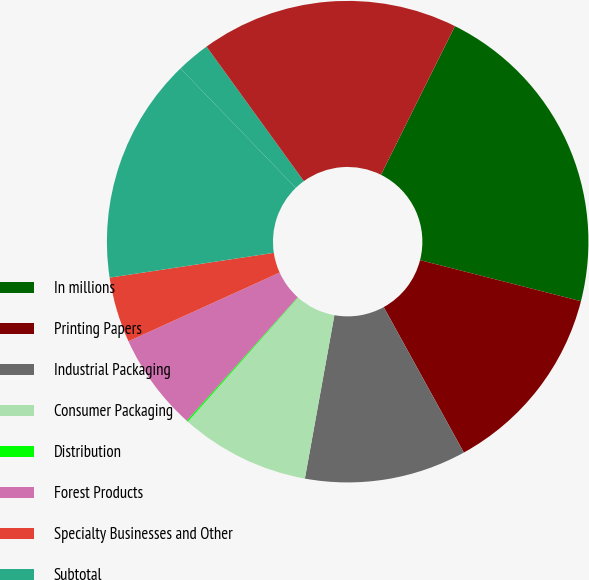<chart> <loc_0><loc_0><loc_500><loc_500><pie_chart><fcel>In millions<fcel>Printing Papers<fcel>Industrial Packaging<fcel>Consumer Packaging<fcel>Distribution<fcel>Forest Products<fcel>Specialty Businesses and Other<fcel>Subtotal<fcel>Corporate and other<fcel>Total from continuing<nl><fcel>21.63%<fcel>13.01%<fcel>10.86%<fcel>8.71%<fcel>0.1%<fcel>6.56%<fcel>4.4%<fcel>15.17%<fcel>2.25%<fcel>17.32%<nl></chart> 